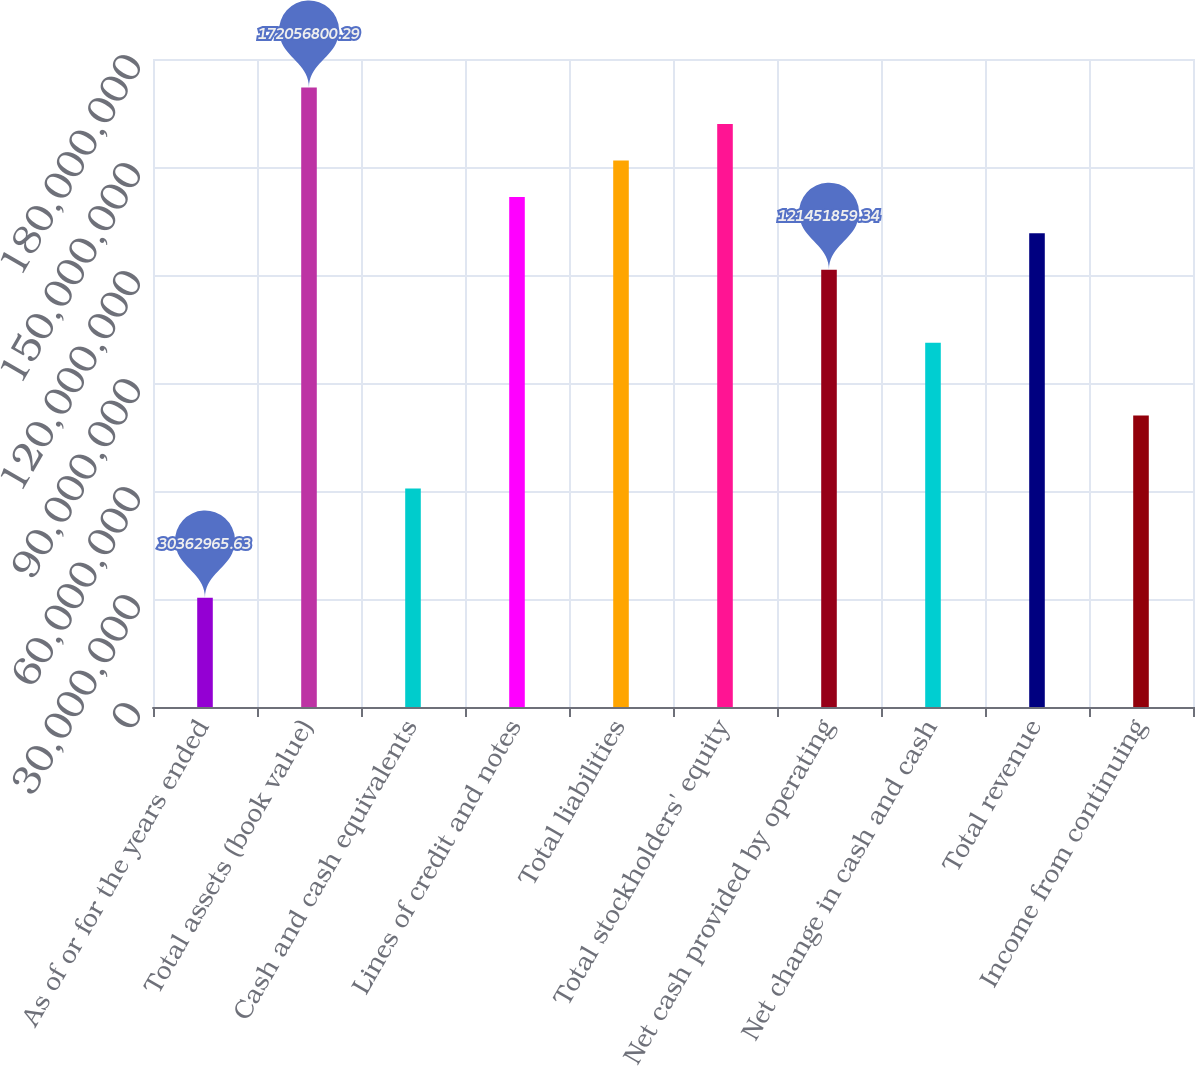Convert chart to OTSL. <chart><loc_0><loc_0><loc_500><loc_500><bar_chart><fcel>As of or for the years ended<fcel>Total assets (book value)<fcel>Cash and cash equivalents<fcel>Lines of credit and notes<fcel>Total liabilities<fcel>Total stockholders' equity<fcel>Net cash provided by operating<fcel>Net change in cash and cash<fcel>Total revenue<fcel>Income from continuing<nl><fcel>3.0363e+07<fcel>1.72057e+08<fcel>6.07259e+07<fcel>1.41694e+08<fcel>1.51815e+08<fcel>1.61936e+08<fcel>1.21452e+08<fcel>1.0121e+08<fcel>1.31573e+08<fcel>8.09679e+07<nl></chart> 